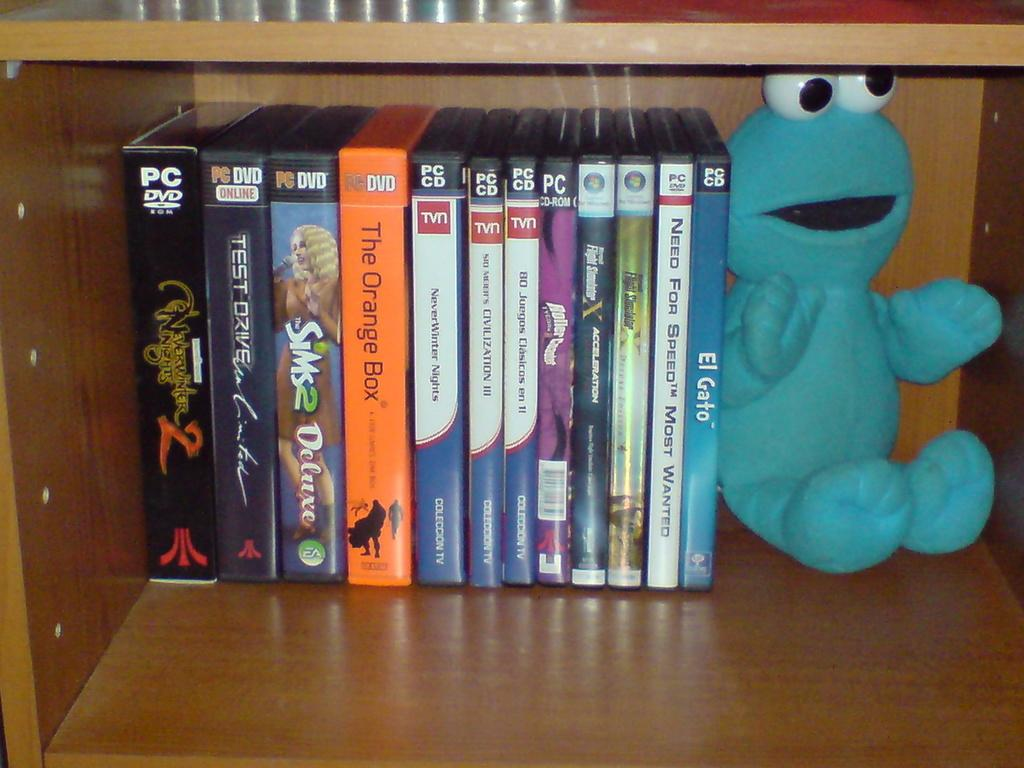<image>
Give a short and clear explanation of the subsequent image. The Sims 2 Deluxe is one of the computer games that can be found on this shelf 